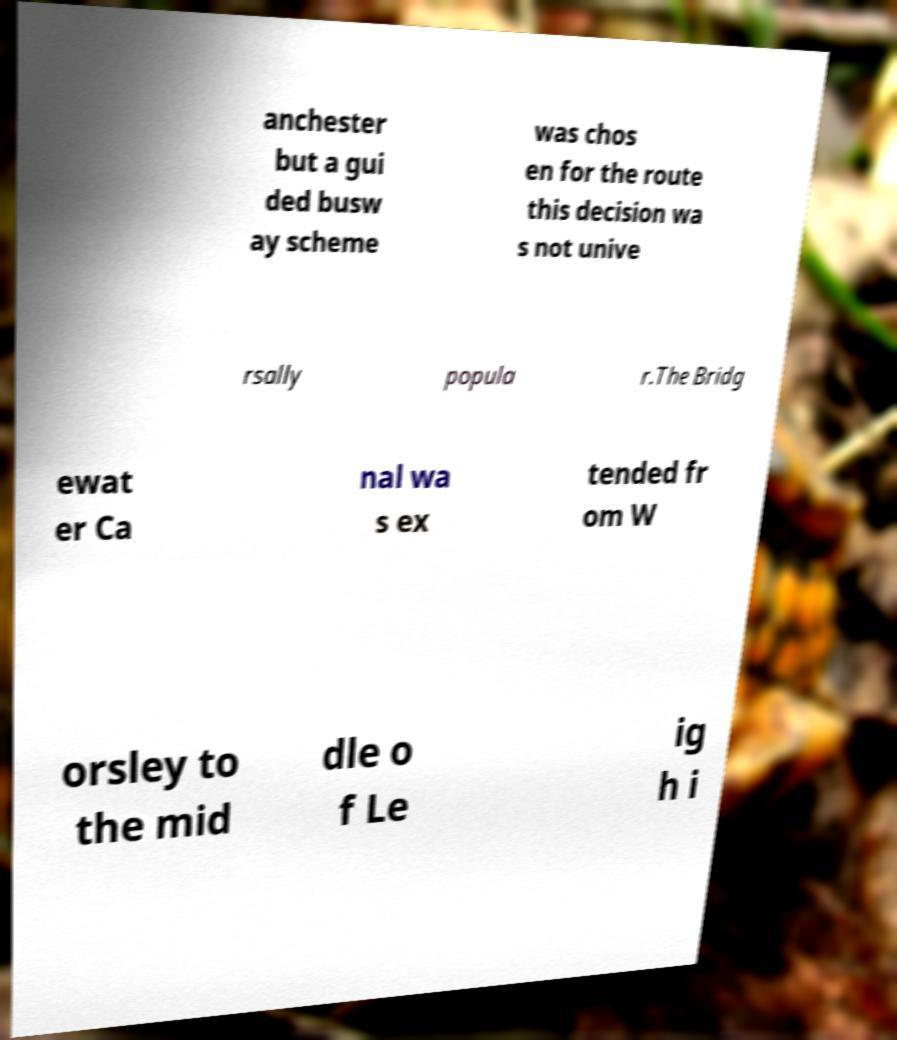Could you extract and type out the text from this image? anchester but a gui ded busw ay scheme was chos en for the route this decision wa s not unive rsally popula r.The Bridg ewat er Ca nal wa s ex tended fr om W orsley to the mid dle o f Le ig h i 